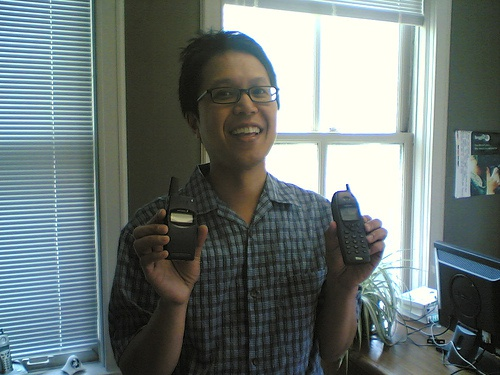Describe the objects in this image and their specific colors. I can see people in lightblue, black, gray, and purple tones, tv in lightblue, black, gray, and blue tones, potted plant in lightblue, teal, gray, black, and darkgray tones, cell phone in lightblue, black, gray, and blue tones, and cell phone in lightblue, black, olive, gray, and tan tones in this image. 